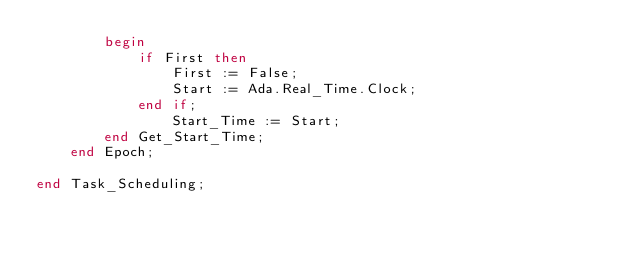Convert code to text. <code><loc_0><loc_0><loc_500><loc_500><_Ada_>        begin
            if First then
                First := False;
                Start := Ada.Real_Time.Clock;
            end if;
                Start_Time := Start;
        end Get_Start_Time;
    end Epoch;

end Task_Scheduling;</code> 